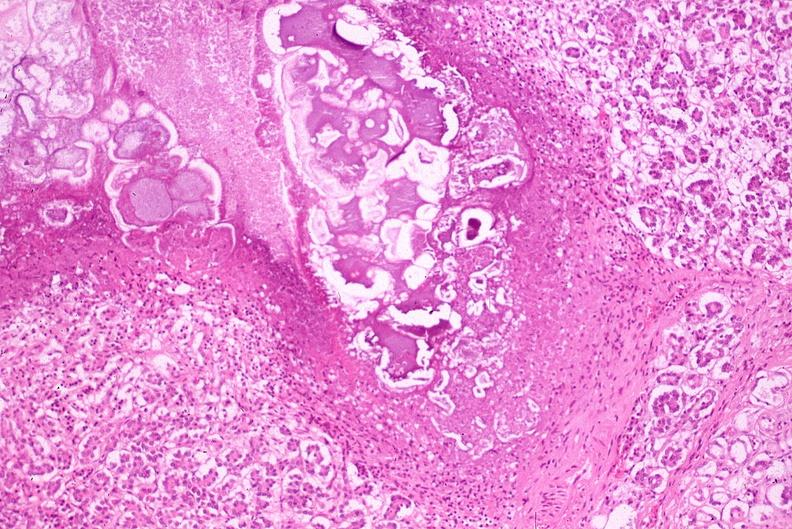what does this image show?
Answer the question using a single word or phrase. Pancreatic fat necrosis 